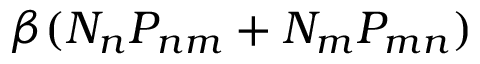<formula> <loc_0><loc_0><loc_500><loc_500>\beta ( N _ { n } P _ { n m } + N _ { m } P _ { m n } )</formula> 